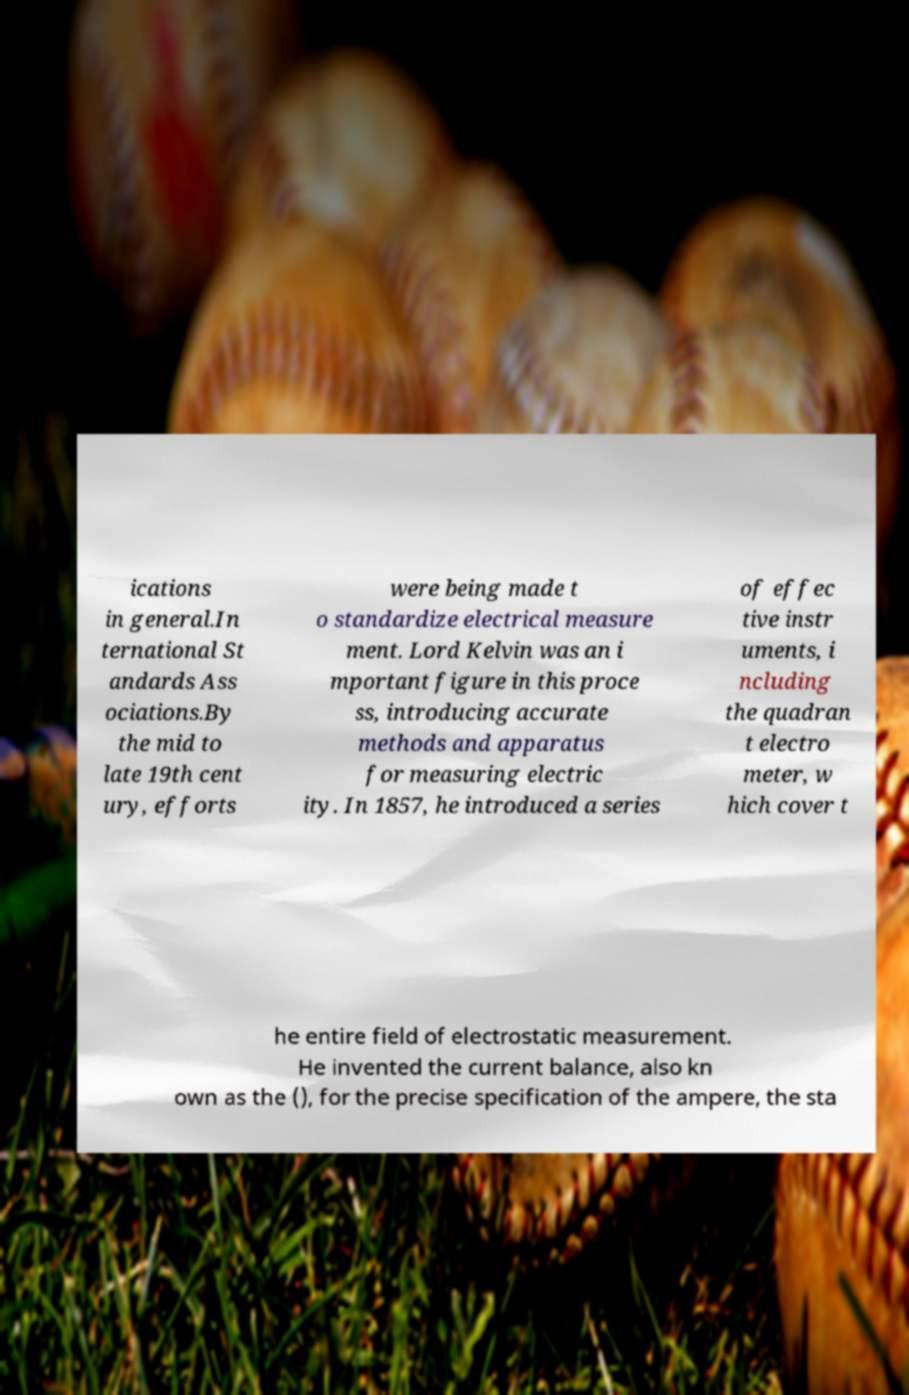I need the written content from this picture converted into text. Can you do that? ications in general.In ternational St andards Ass ociations.By the mid to late 19th cent ury, efforts were being made t o standardize electrical measure ment. Lord Kelvin was an i mportant figure in this proce ss, introducing accurate methods and apparatus for measuring electric ity. In 1857, he introduced a series of effec tive instr uments, i ncluding the quadran t electro meter, w hich cover t he entire field of electrostatic measurement. He invented the current balance, also kn own as the (), for the precise specification of the ampere, the sta 